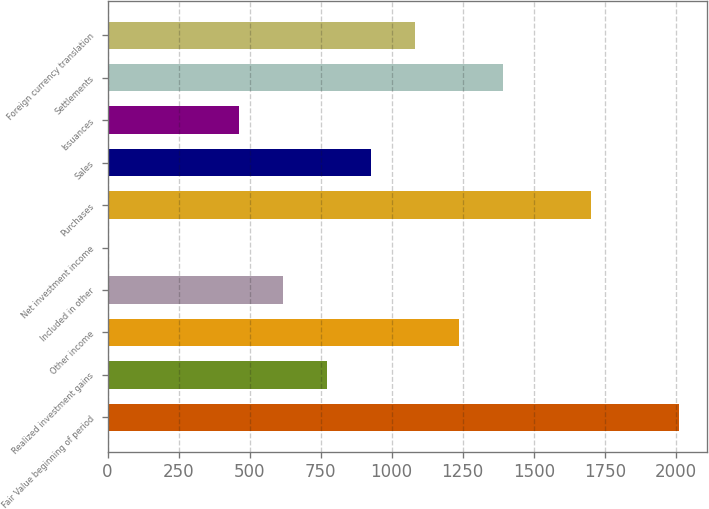<chart> <loc_0><loc_0><loc_500><loc_500><bar_chart><fcel>Fair Value beginning of period<fcel>Realized investment gains<fcel>Other income<fcel>Included in other<fcel>Net investment income<fcel>Purchases<fcel>Sales<fcel>Issuances<fcel>Settlements<fcel>Foreign currency translation<nl><fcel>2010.91<fcel>773.71<fcel>1237.66<fcel>619.06<fcel>0.46<fcel>1701.61<fcel>928.36<fcel>464.41<fcel>1392.31<fcel>1083.01<nl></chart> 